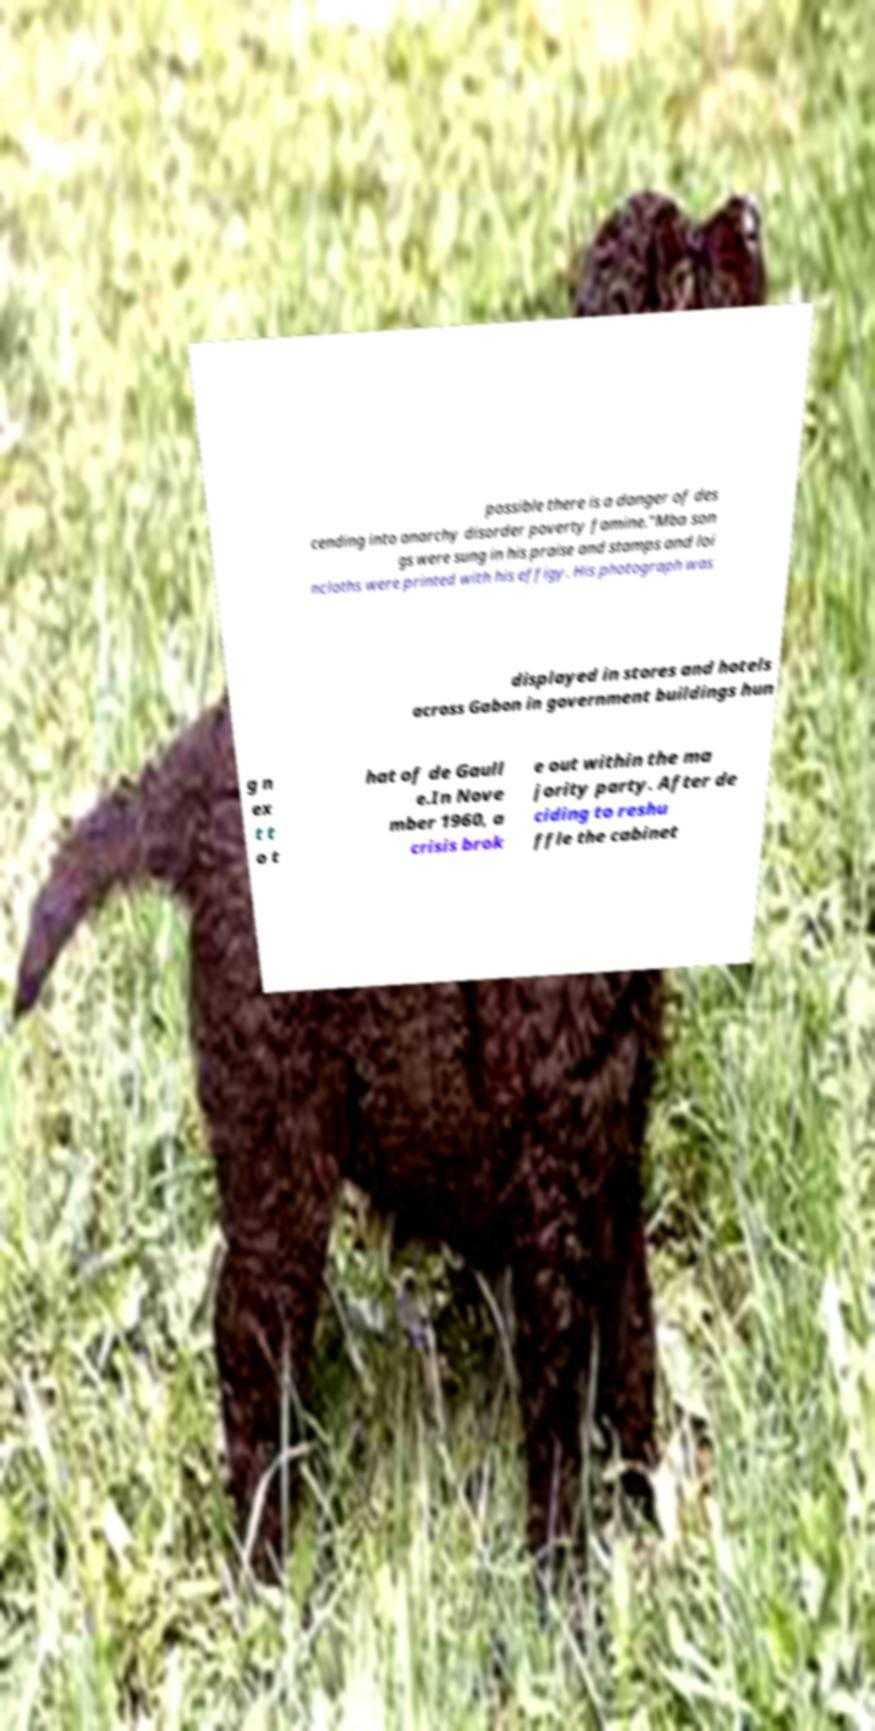I need the written content from this picture converted into text. Can you do that? possible there is a danger of des cending into anarchy disorder poverty famine."Mba son gs were sung in his praise and stamps and loi ncloths were printed with his effigy. His photograph was displayed in stores and hotels across Gabon in government buildings hun g n ex t t o t hat of de Gaull e.In Nove mber 1960, a crisis brok e out within the ma jority party. After de ciding to reshu ffle the cabinet 